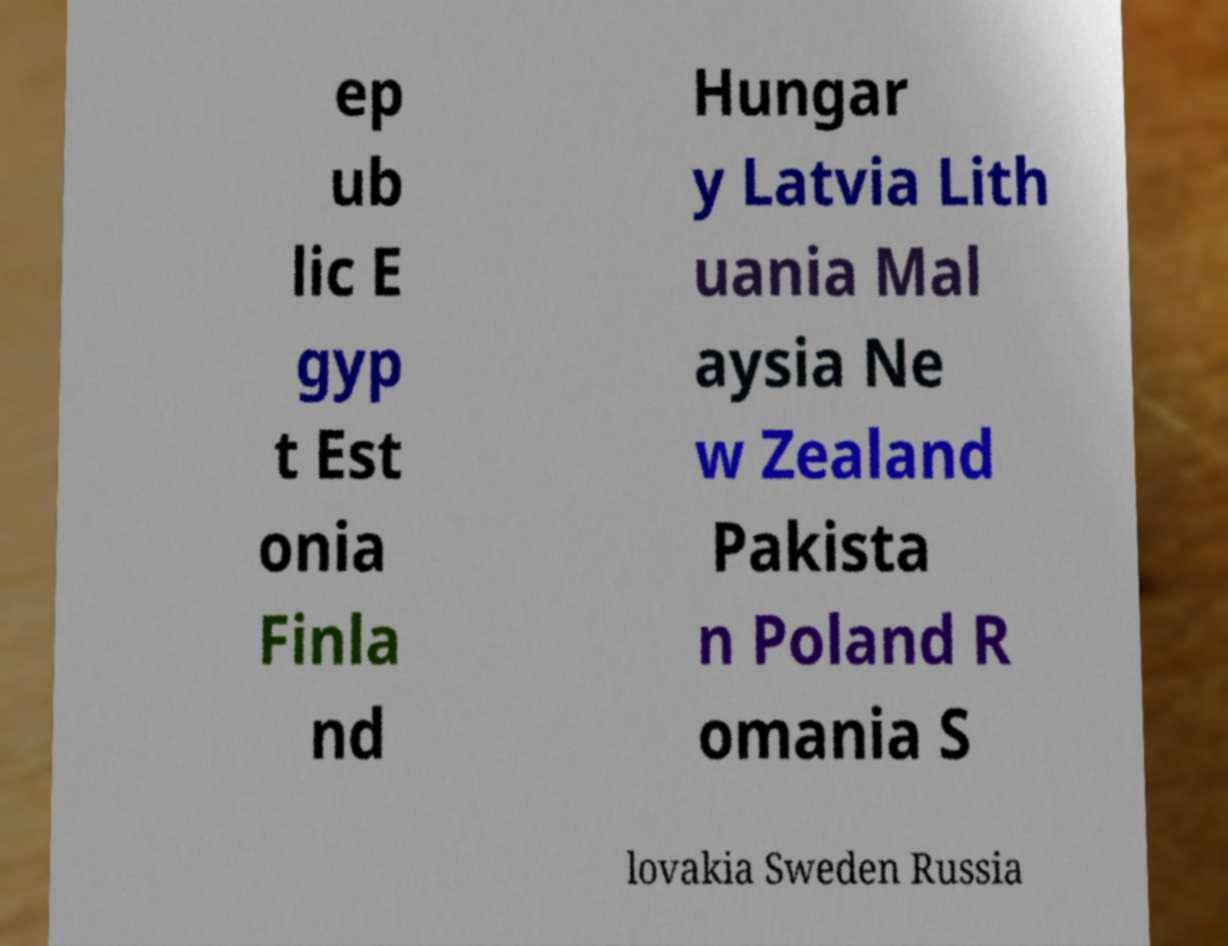Could you assist in decoding the text presented in this image and type it out clearly? ep ub lic E gyp t Est onia Finla nd Hungar y Latvia Lith uania Mal aysia Ne w Zealand Pakista n Poland R omania S lovakia Sweden Russia 